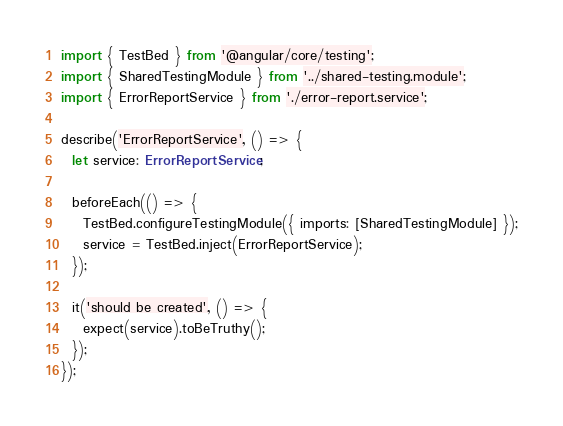Convert code to text. <code><loc_0><loc_0><loc_500><loc_500><_TypeScript_>import { TestBed } from '@angular/core/testing';
import { SharedTestingModule } from '../shared-testing.module';
import { ErrorReportService } from './error-report.service';

describe('ErrorReportService', () => {
  let service: ErrorReportService;

  beforeEach(() => {
    TestBed.configureTestingModule({ imports: [SharedTestingModule] });
    service = TestBed.inject(ErrorReportService);
  });

  it('should be created', () => {
    expect(service).toBeTruthy();
  });
});
</code> 